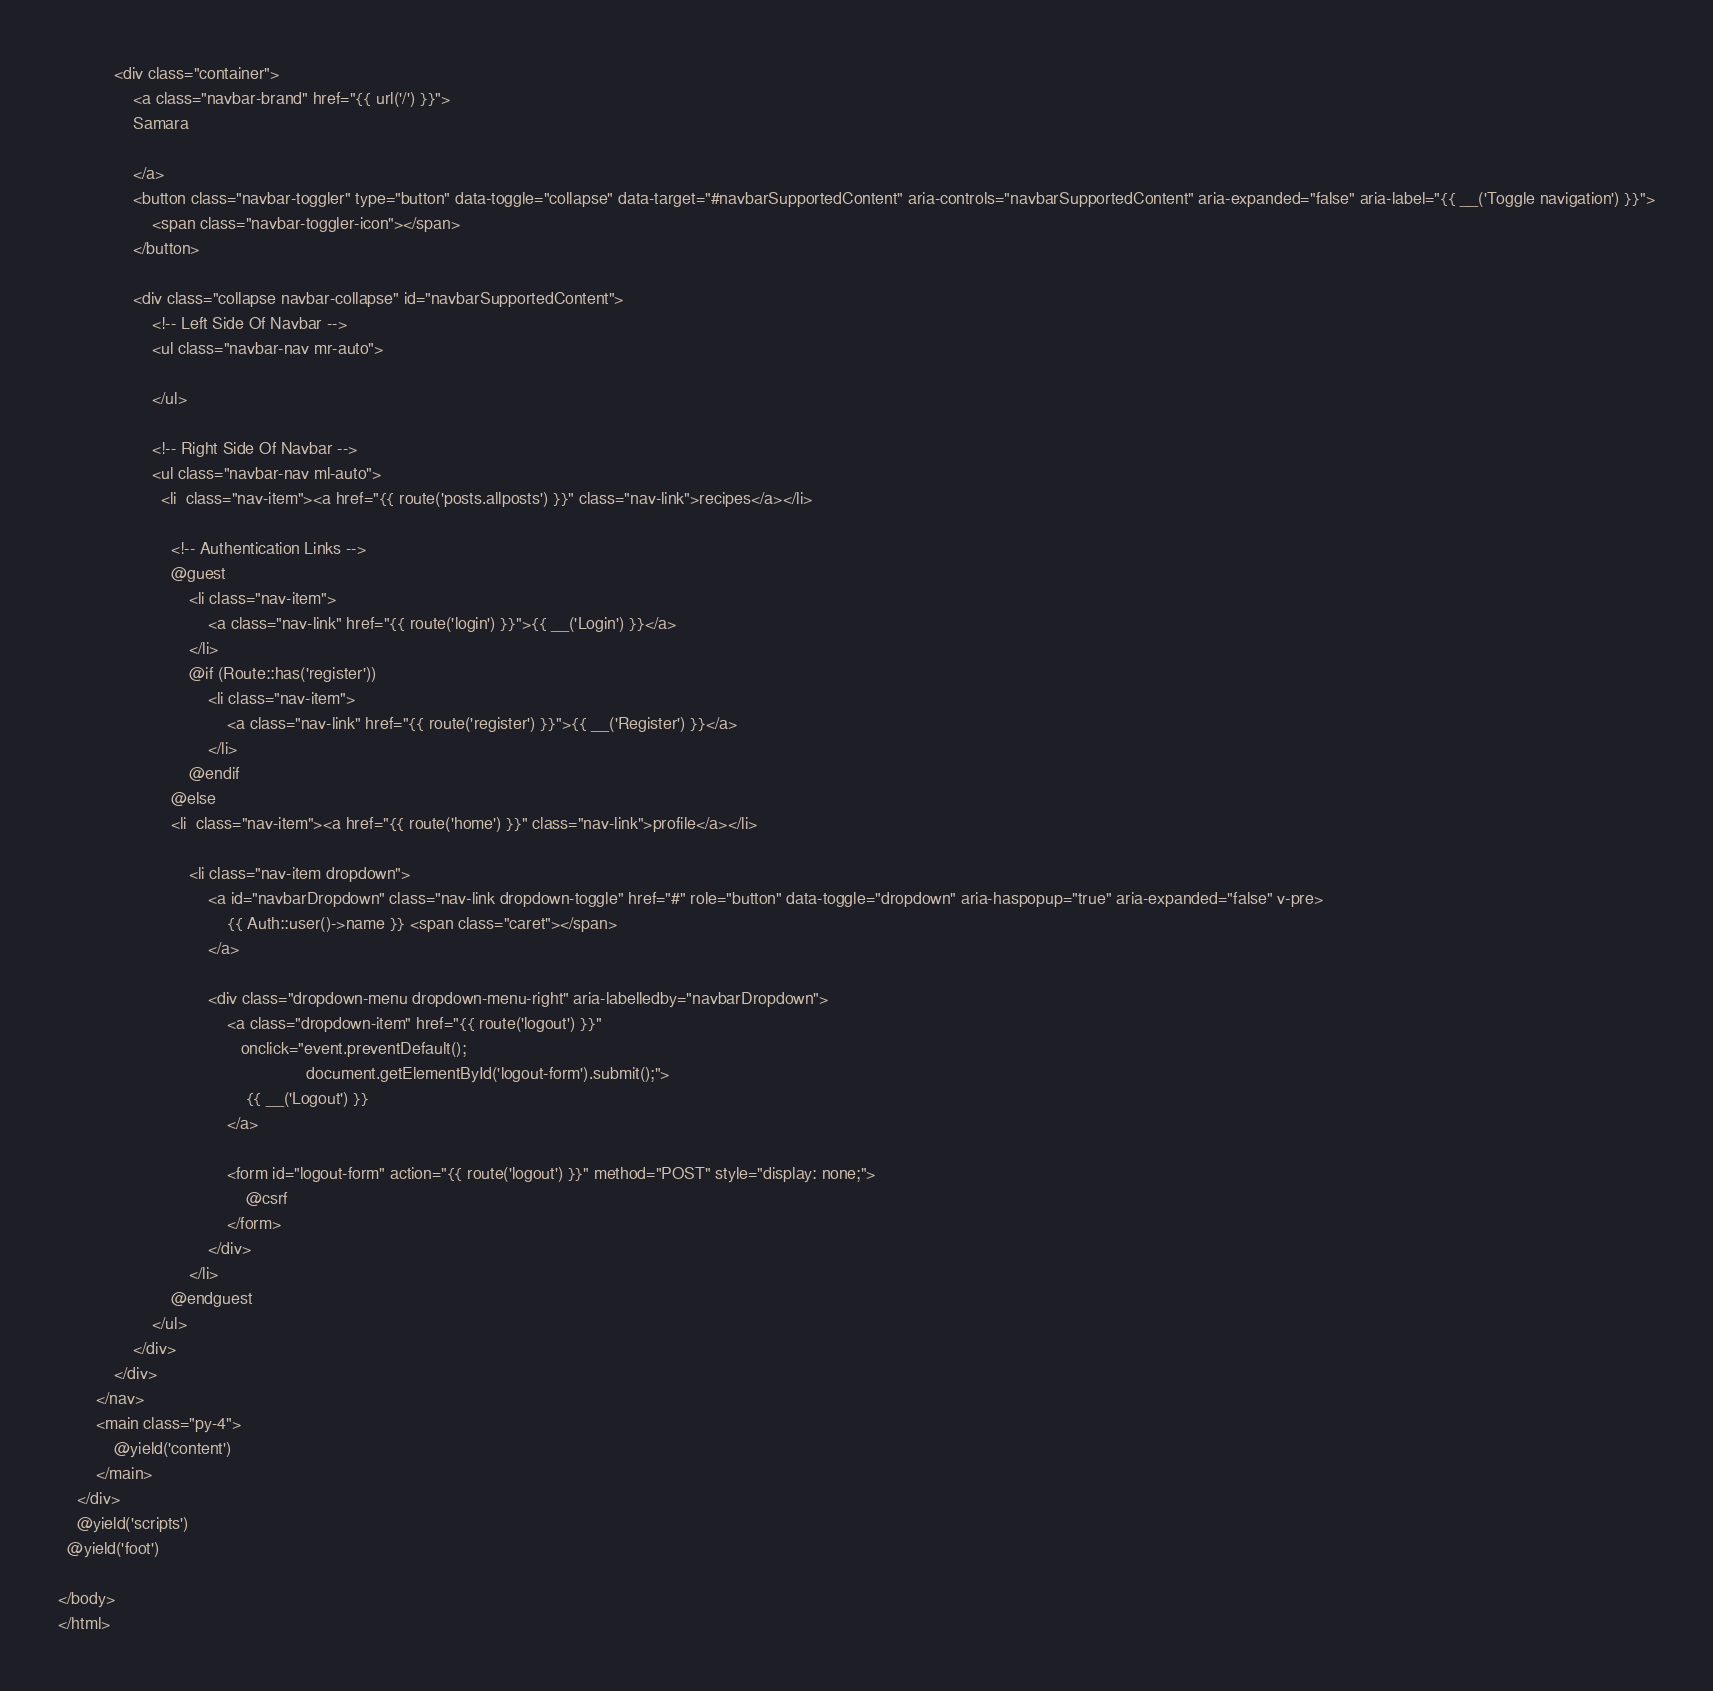Convert code to text. <code><loc_0><loc_0><loc_500><loc_500><_PHP_>            <div class="container">
                <a class="navbar-brand" href="{{ url('/') }}">
                Samara

                </a>
                <button class="navbar-toggler" type="button" data-toggle="collapse" data-target="#navbarSupportedContent" aria-controls="navbarSupportedContent" aria-expanded="false" aria-label="{{ __('Toggle navigation') }}">
                    <span class="navbar-toggler-icon"></span>
                </button>

                <div class="collapse navbar-collapse" id="navbarSupportedContent">
                    <!-- Left Side Of Navbar -->
                    <ul class="navbar-nav mr-auto">

                    </ul>

                    <!-- Right Side Of Navbar -->
                    <ul class="navbar-nav ml-auto">
                      <li  class="nav-item"><a href="{{ route('posts.allposts') }}" class="nav-link">recipes</a></li>

                        <!-- Authentication Links -->
                        @guest
                            <li class="nav-item">
                                <a class="nav-link" href="{{ route('login') }}">{{ __('Login') }}</a>
                            </li>
                            @if (Route::has('register'))
                                <li class="nav-item">
                                    <a class="nav-link" href="{{ route('register') }}">{{ __('Register') }}</a>
                                </li>
                            @endif
                        @else
                        <li  class="nav-item"><a href="{{ route('home') }}" class="nav-link">profile</a></li>

                            <li class="nav-item dropdown">
                                <a id="navbarDropdown" class="nav-link dropdown-toggle" href="#" role="button" data-toggle="dropdown" aria-haspopup="true" aria-expanded="false" v-pre>
                                    {{ Auth::user()->name }} <span class="caret"></span>
                                </a>

                                <div class="dropdown-menu dropdown-menu-right" aria-labelledby="navbarDropdown">
                                    <a class="dropdown-item" href="{{ route('logout') }}"
                                       onclick="event.preventDefault();
                                                     document.getElementById('logout-form').submit();">
                                        {{ __('Logout') }}
                                    </a>

                                    <form id="logout-form" action="{{ route('logout') }}" method="POST" style="display: none;">
                                        @csrf
                                    </form>
                                </div>
                            </li>
                        @endguest
                    </ul>
                </div>
            </div>
        </nav>
        <main class="py-4">
            @yield('content')
        </main>
    </div>
    @yield('scripts')
  @yield('foot')

</body>
</html>
</code> 